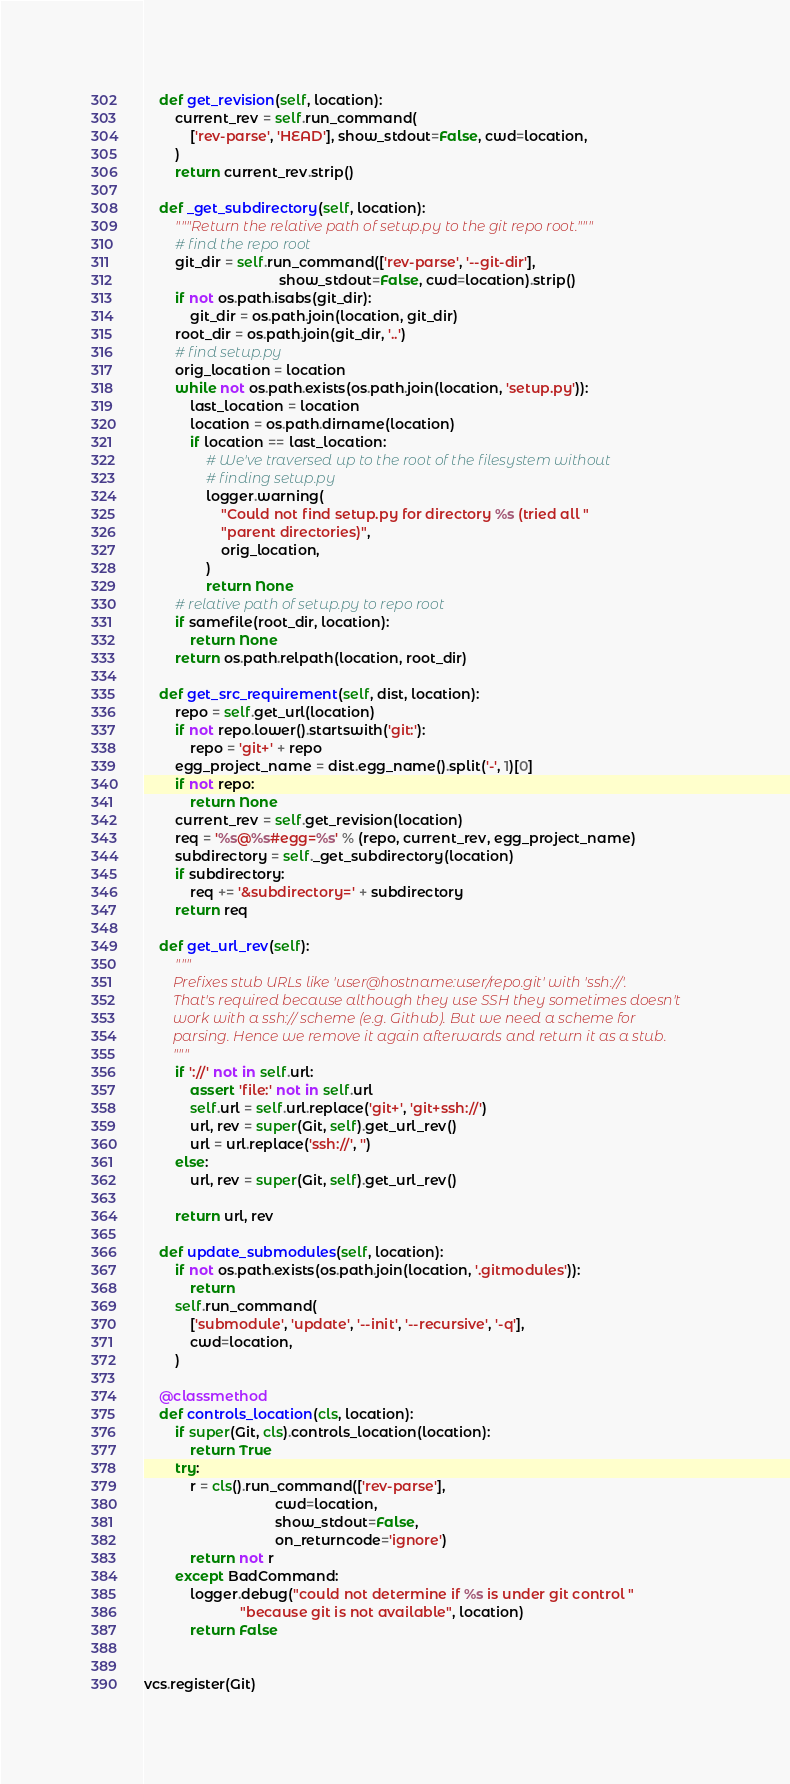Convert code to text. <code><loc_0><loc_0><loc_500><loc_500><_Python_>
    def get_revision(self, location):
        current_rev = self.run_command(
            ['rev-parse', 'HEAD'], show_stdout=False, cwd=location,
        )
        return current_rev.strip()

    def _get_subdirectory(self, location):
        """Return the relative path of setup.py to the git repo root."""
        # find the repo root
        git_dir = self.run_command(['rev-parse', '--git-dir'],
                                   show_stdout=False, cwd=location).strip()
        if not os.path.isabs(git_dir):
            git_dir = os.path.join(location, git_dir)
        root_dir = os.path.join(git_dir, '..')
        # find setup.py
        orig_location = location
        while not os.path.exists(os.path.join(location, 'setup.py')):
            last_location = location
            location = os.path.dirname(location)
            if location == last_location:
                # We've traversed up to the root of the filesystem without
                # finding setup.py
                logger.warning(
                    "Could not find setup.py for directory %s (tried all "
                    "parent directories)",
                    orig_location,
                )
                return None
        # relative path of setup.py to repo root
        if samefile(root_dir, location):
            return None
        return os.path.relpath(location, root_dir)

    def get_src_requirement(self, dist, location):
        repo = self.get_url(location)
        if not repo.lower().startswith('git:'):
            repo = 'git+' + repo
        egg_project_name = dist.egg_name().split('-', 1)[0]
        if not repo:
            return None
        current_rev = self.get_revision(location)
        req = '%s@%s#egg=%s' % (repo, current_rev, egg_project_name)
        subdirectory = self._get_subdirectory(location)
        if subdirectory:
            req += '&subdirectory=' + subdirectory
        return req

    def get_url_rev(self):
        """
        Prefixes stub URLs like 'user@hostname:user/repo.git' with 'ssh://'.
        That's required because although they use SSH they sometimes doesn't
        work with a ssh:// scheme (e.g. Github). But we need a scheme for
        parsing. Hence we remove it again afterwards and return it as a stub.
        """
        if '://' not in self.url:
            assert 'file:' not in self.url
            self.url = self.url.replace('git+', 'git+ssh://')
            url, rev = super(Git, self).get_url_rev()
            url = url.replace('ssh://', '')
        else:
            url, rev = super(Git, self).get_url_rev()

        return url, rev

    def update_submodules(self, location):
        if not os.path.exists(os.path.join(location, '.gitmodules')):
            return
        self.run_command(
            ['submodule', 'update', '--init', '--recursive', '-q'],
            cwd=location,
        )

    @classmethod
    def controls_location(cls, location):
        if super(Git, cls).controls_location(location):
            return True
        try:
            r = cls().run_command(['rev-parse'],
                                  cwd=location,
                                  show_stdout=False,
                                  on_returncode='ignore')
            return not r
        except BadCommand:
            logger.debug("could not determine if %s is under git control "
                         "because git is not available", location)
            return False


vcs.register(Git)
</code> 